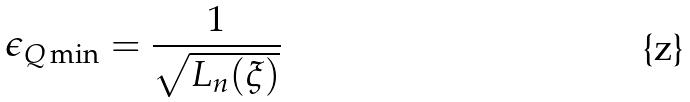Convert formula to latex. <formula><loc_0><loc_0><loc_500><loc_500>\epsilon _ { Q \min } = \frac { 1 } { \sqrt { L _ { n } ( \xi ) } }</formula> 